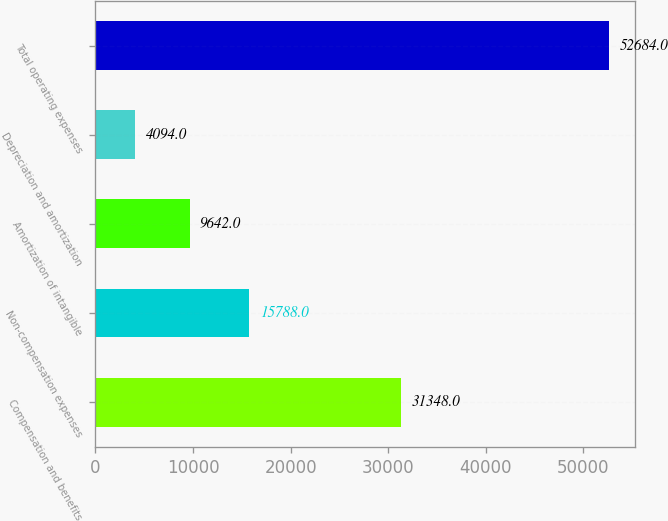<chart> <loc_0><loc_0><loc_500><loc_500><bar_chart><fcel>Compensation and benefits<fcel>Non-compensation expenses<fcel>Amortization of intangible<fcel>Depreciation and amortization<fcel>Total operating expenses<nl><fcel>31348<fcel>15788<fcel>9642<fcel>4094<fcel>52684<nl></chart> 